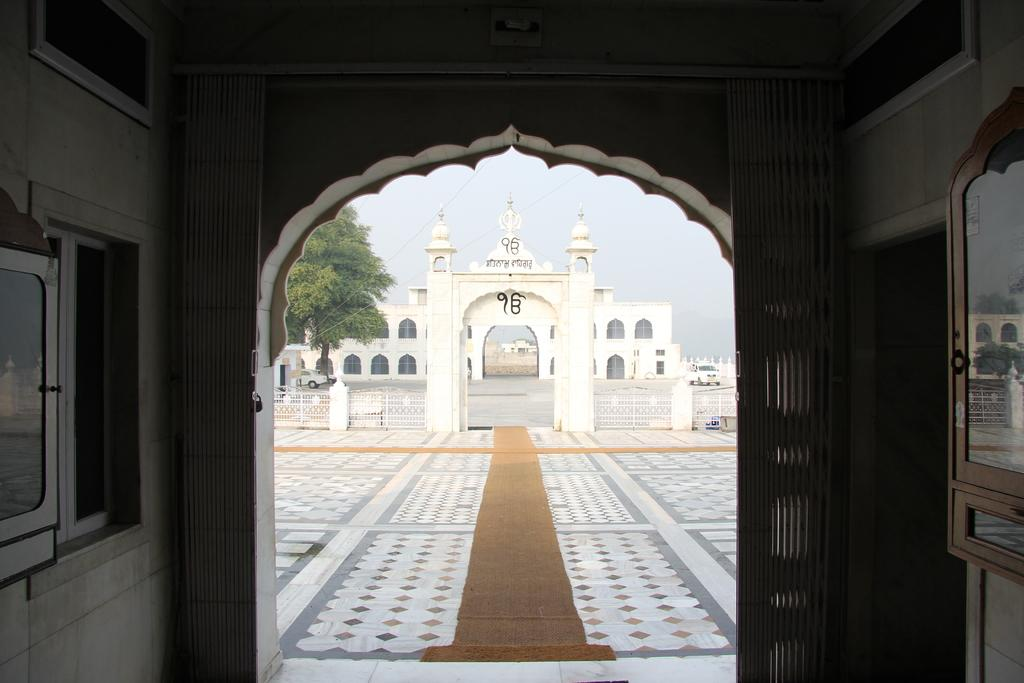What type of structure is present in the image? There is a building in the image. Can you describe the color of the building? The building is white. What other elements can be seen in the image? There is a window and trees in the image. What is the color of the trees? The trees are green. What can be seen in the background of the image? The sky is visible in the image. What is the color of the sky? The sky is white. What type of sense is being used by the trees in the image? Trees do not have senses; they are inanimate objects. Is there a cemetery present in the image? There is no mention of a cemetery in the provided facts, so it cannot be determined from the image. 